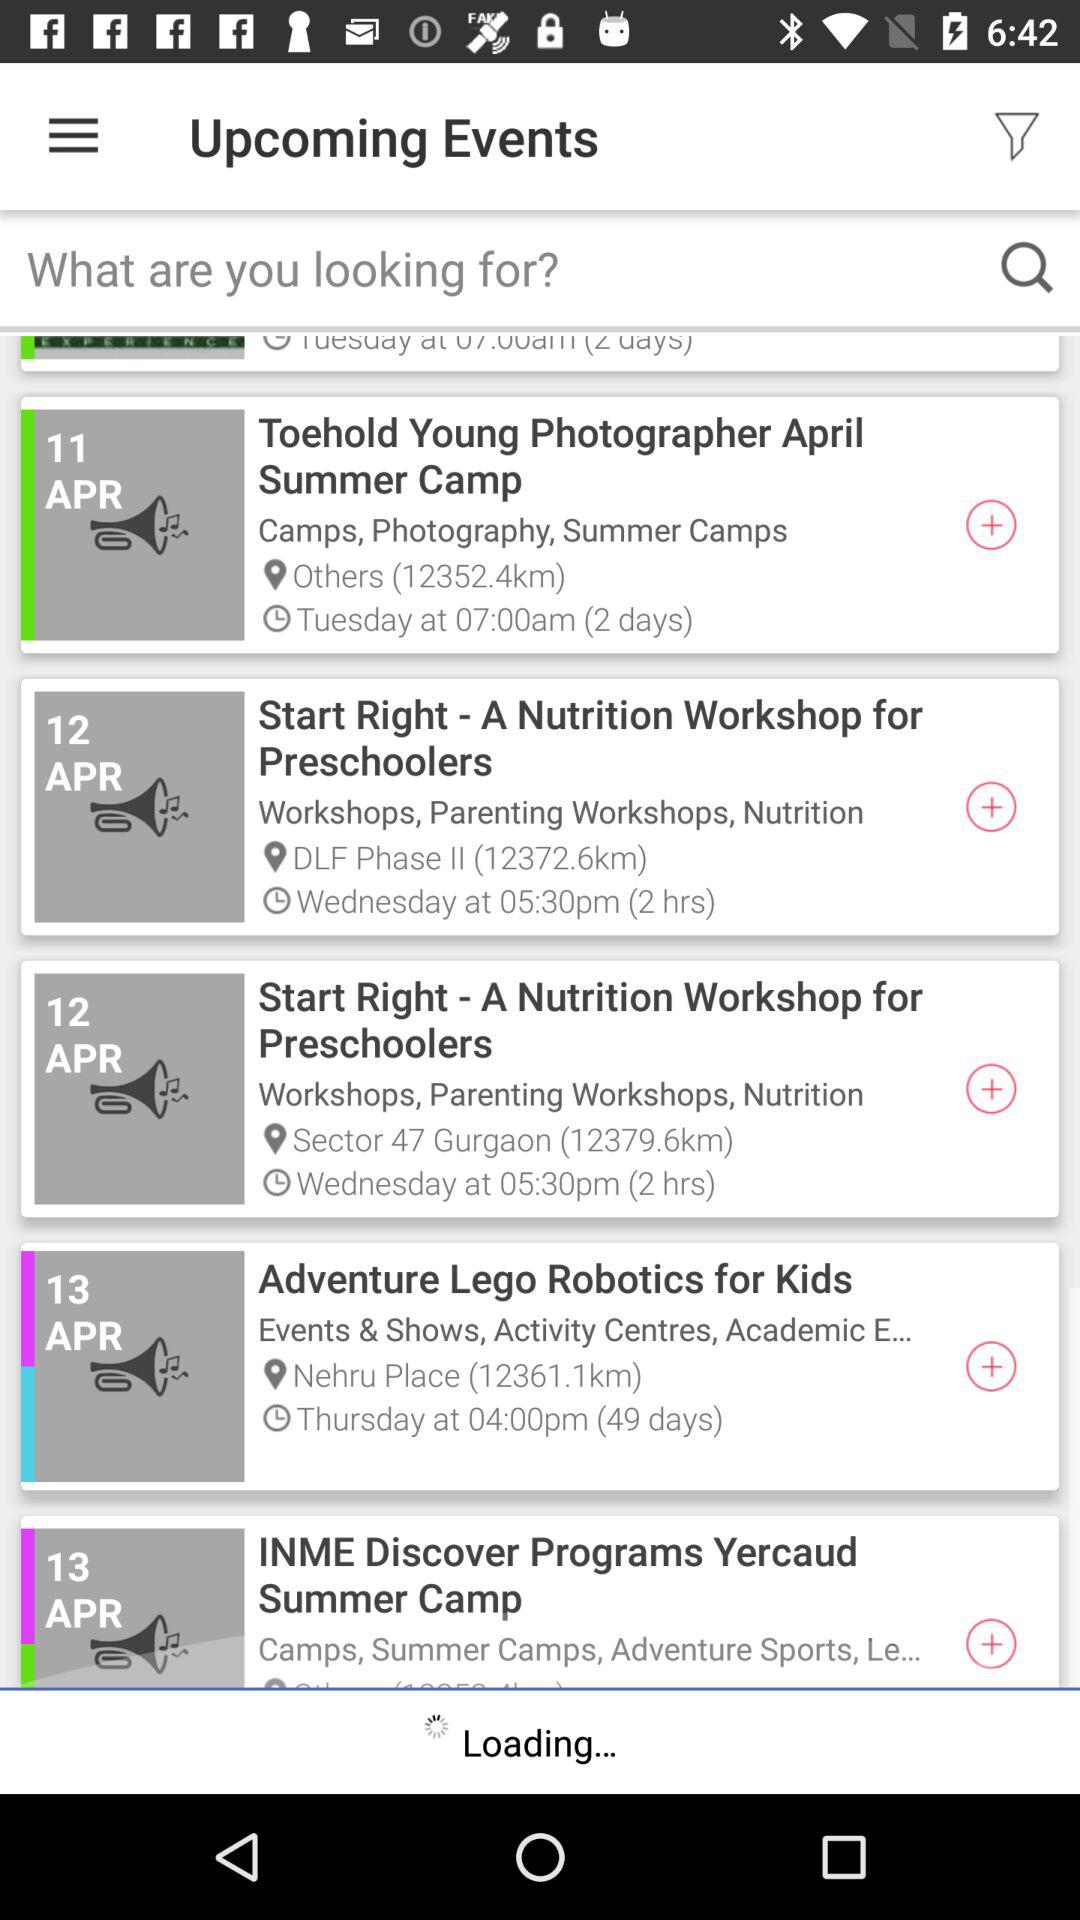What is the user looking for?
When the provided information is insufficient, respond with <no answer>. <no answer> 